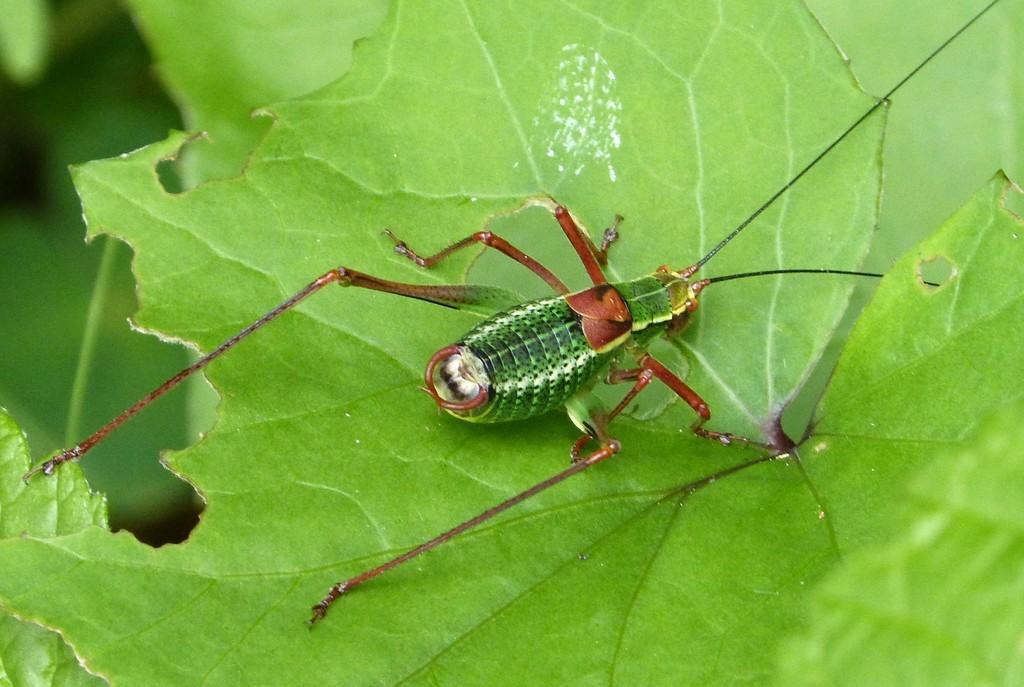What is present on the leaf in the image? There is an insect in the image. What is the insect doing on the leaf? The insect is laying on the leaf. What colors can be seen on the insect? The insect has green and brown coloration. What type of celery is the pig eating in the image? There is no pig or celery present in the image; it features an insect laying on a leaf. Can you see a sail in the image? There is no sail present in the image. 